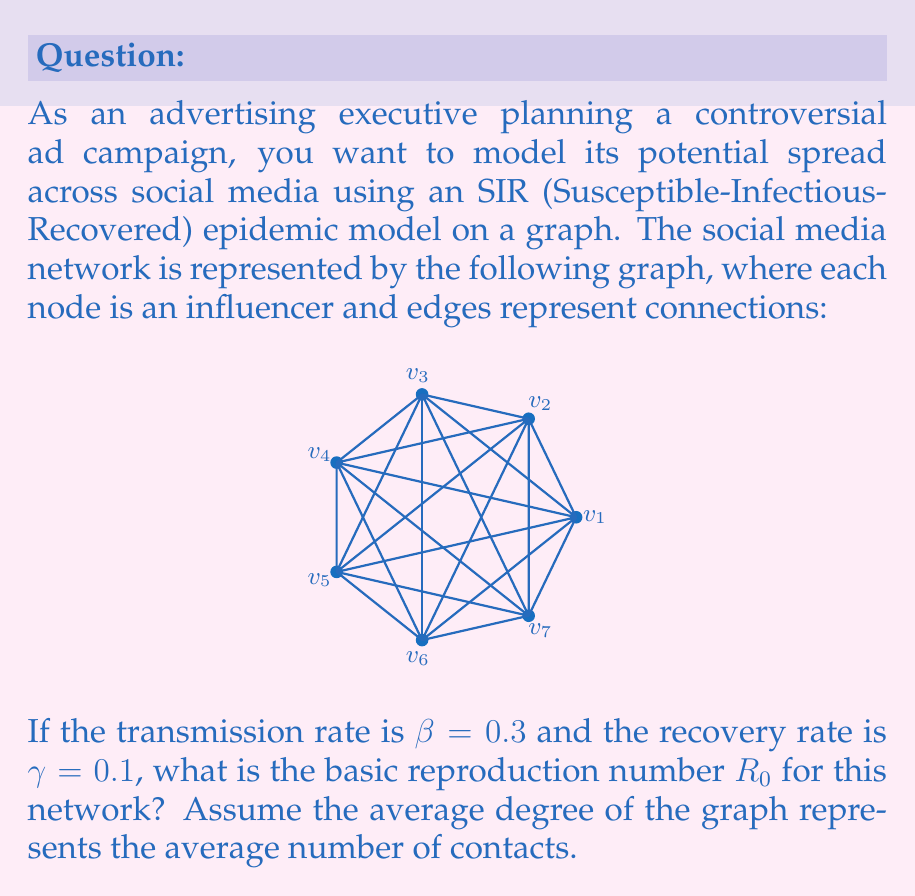Give your solution to this math problem. To solve this problem, we'll follow these steps:

1) First, we need to calculate the average degree of the graph. The degree of a node is the number of edges connected to it.

   In this complete graph with 7 nodes, each node is connected to all other nodes.
   So, the degree of each node is 6.

   Average degree = $\frac{\text{Sum of all degrees}}{\text{Number of nodes}} = \frac{6 \times 7}{7} = 6$

2) In an SIR model on a network, the basic reproduction number $R_0$ is given by:

   $$R_0 = \frac{\beta \langle k \rangle}{\gamma}$$

   Where:
   - $\beta$ is the transmission rate
   - $\langle k \rangle$ is the average degree of the network
   - $\gamma$ is the recovery rate

3) We have:
   - $\beta = 0.3$
   - $\langle k \rangle = 6$
   - $\gamma = 0.1$

4) Plugging these values into the formula:

   $$R_0 = \frac{0.3 \times 6}{0.1} = \frac{1.8}{0.1} = 18$$

Therefore, the basic reproduction number $R_0$ for this network is 18.
Answer: 18 